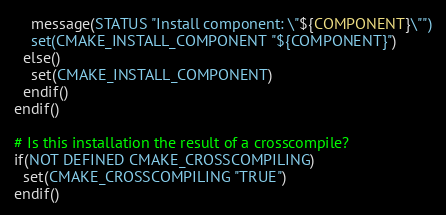Convert code to text. <code><loc_0><loc_0><loc_500><loc_500><_CMake_>    message(STATUS "Install component: \"${COMPONENT}\"")
    set(CMAKE_INSTALL_COMPONENT "${COMPONENT}")
  else()
    set(CMAKE_INSTALL_COMPONENT)
  endif()
endif()

# Is this installation the result of a crosscompile?
if(NOT DEFINED CMAKE_CROSSCOMPILING)
  set(CMAKE_CROSSCOMPILING "TRUE")
endif()

</code> 